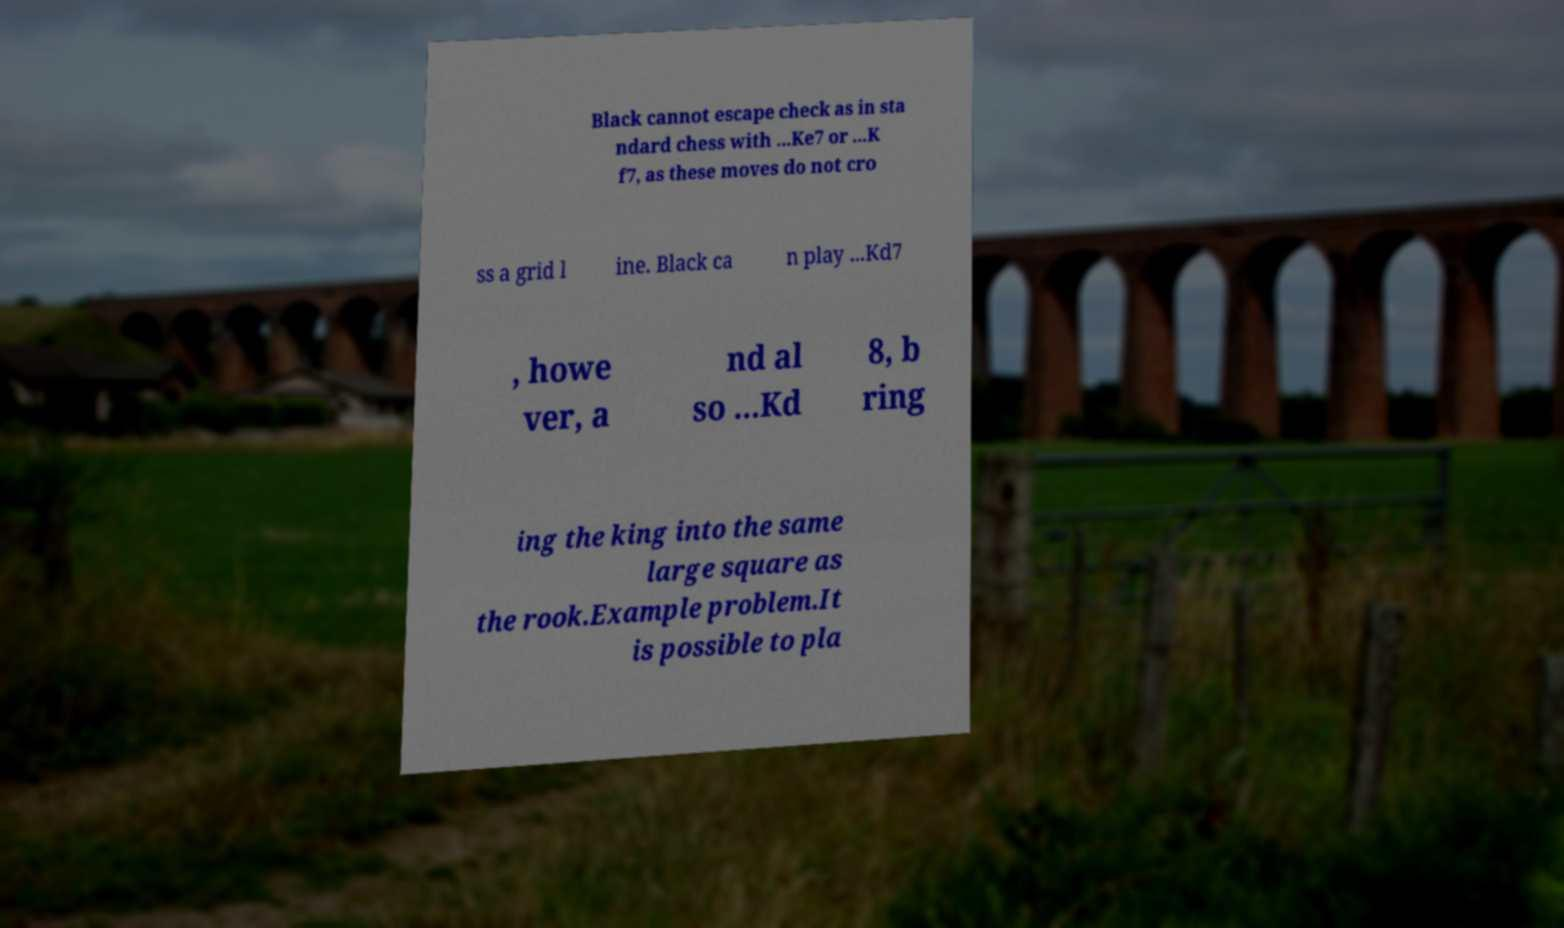For documentation purposes, I need the text within this image transcribed. Could you provide that? Black cannot escape check as in sta ndard chess with ...Ke7 or ...K f7, as these moves do not cro ss a grid l ine. Black ca n play ...Kd7 , howe ver, a nd al so ...Kd 8, b ring ing the king into the same large square as the rook.Example problem.It is possible to pla 